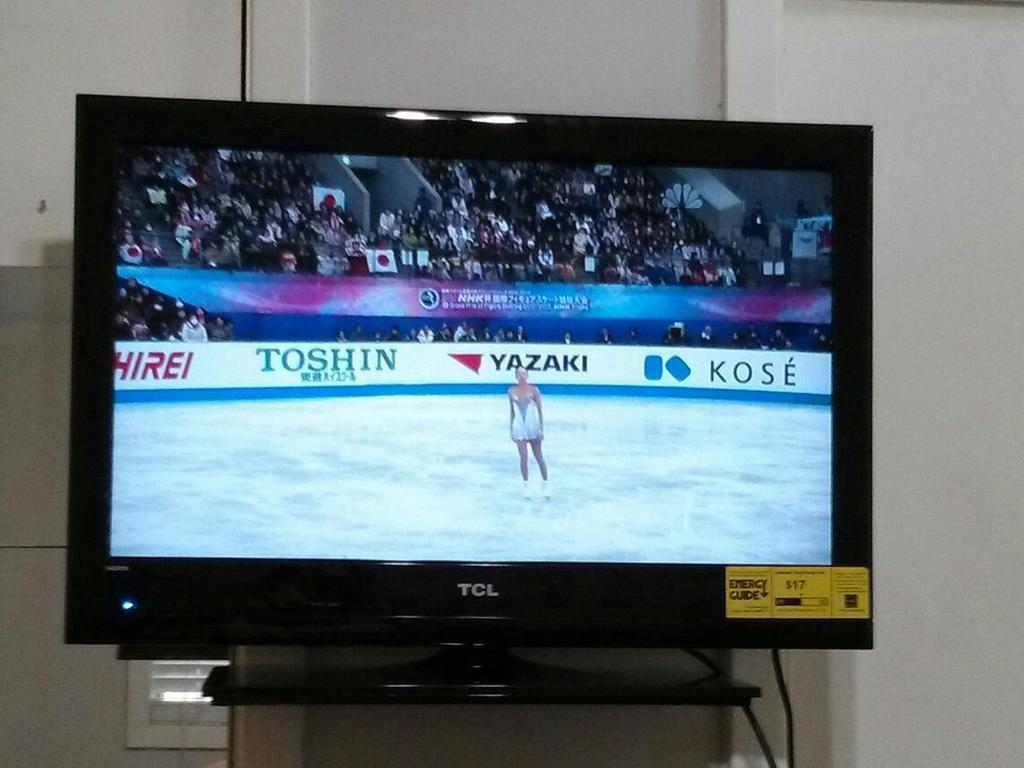Provide a one-sentence caption for the provided image. A TCL brand television displays an ice skater in mid-routine. 